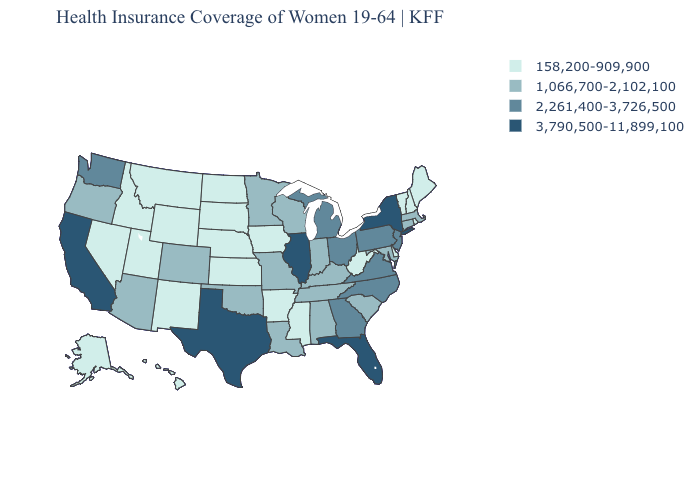Does Kansas have a lower value than Oklahoma?
Concise answer only. Yes. Name the states that have a value in the range 2,261,400-3,726,500?
Answer briefly. Georgia, Michigan, New Jersey, North Carolina, Ohio, Pennsylvania, Virginia, Washington. Name the states that have a value in the range 1,066,700-2,102,100?
Concise answer only. Alabama, Arizona, Colorado, Connecticut, Indiana, Kentucky, Louisiana, Maryland, Massachusetts, Minnesota, Missouri, Oklahoma, Oregon, South Carolina, Tennessee, Wisconsin. Name the states that have a value in the range 1,066,700-2,102,100?
Concise answer only. Alabama, Arizona, Colorado, Connecticut, Indiana, Kentucky, Louisiana, Maryland, Massachusetts, Minnesota, Missouri, Oklahoma, Oregon, South Carolina, Tennessee, Wisconsin. How many symbols are there in the legend?
Write a very short answer. 4. Name the states that have a value in the range 2,261,400-3,726,500?
Give a very brief answer. Georgia, Michigan, New Jersey, North Carolina, Ohio, Pennsylvania, Virginia, Washington. Does Indiana have the same value as Ohio?
Keep it brief. No. Does Kentucky have a higher value than Nevada?
Short answer required. Yes. What is the value of Virginia?
Quick response, please. 2,261,400-3,726,500. Does the map have missing data?
Keep it brief. No. Does the map have missing data?
Answer briefly. No. What is the value of Colorado?
Write a very short answer. 1,066,700-2,102,100. What is the lowest value in the West?
Keep it brief. 158,200-909,900. What is the value of Illinois?
Short answer required. 3,790,500-11,899,100. Among the states that border Texas , which have the lowest value?
Answer briefly. Arkansas, New Mexico. 